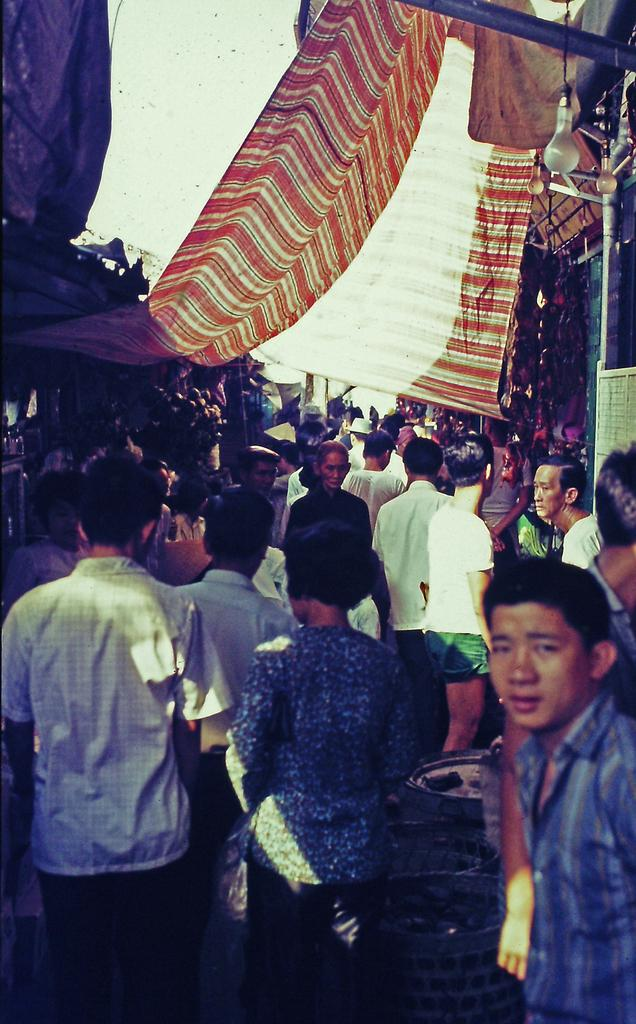Who or what can be seen in the image? There are people in the image. What structures are visible in the background? There are sheds, lights, and tents in the background of the image. What objects are at the bottom of the image? There are objects at the bottom of the image, but their specific nature is not mentioned in the facts. Can you describe the setting of the image? The image appears to be set in an outdoor area with sheds, lights, and tents in the background. What type of kettle is being used to cook the pancake in the image? There is no kettle or pancake present in the image. Can you tell me where the mom is located in the image? There is no mention of a mom or any specific person in the image. 